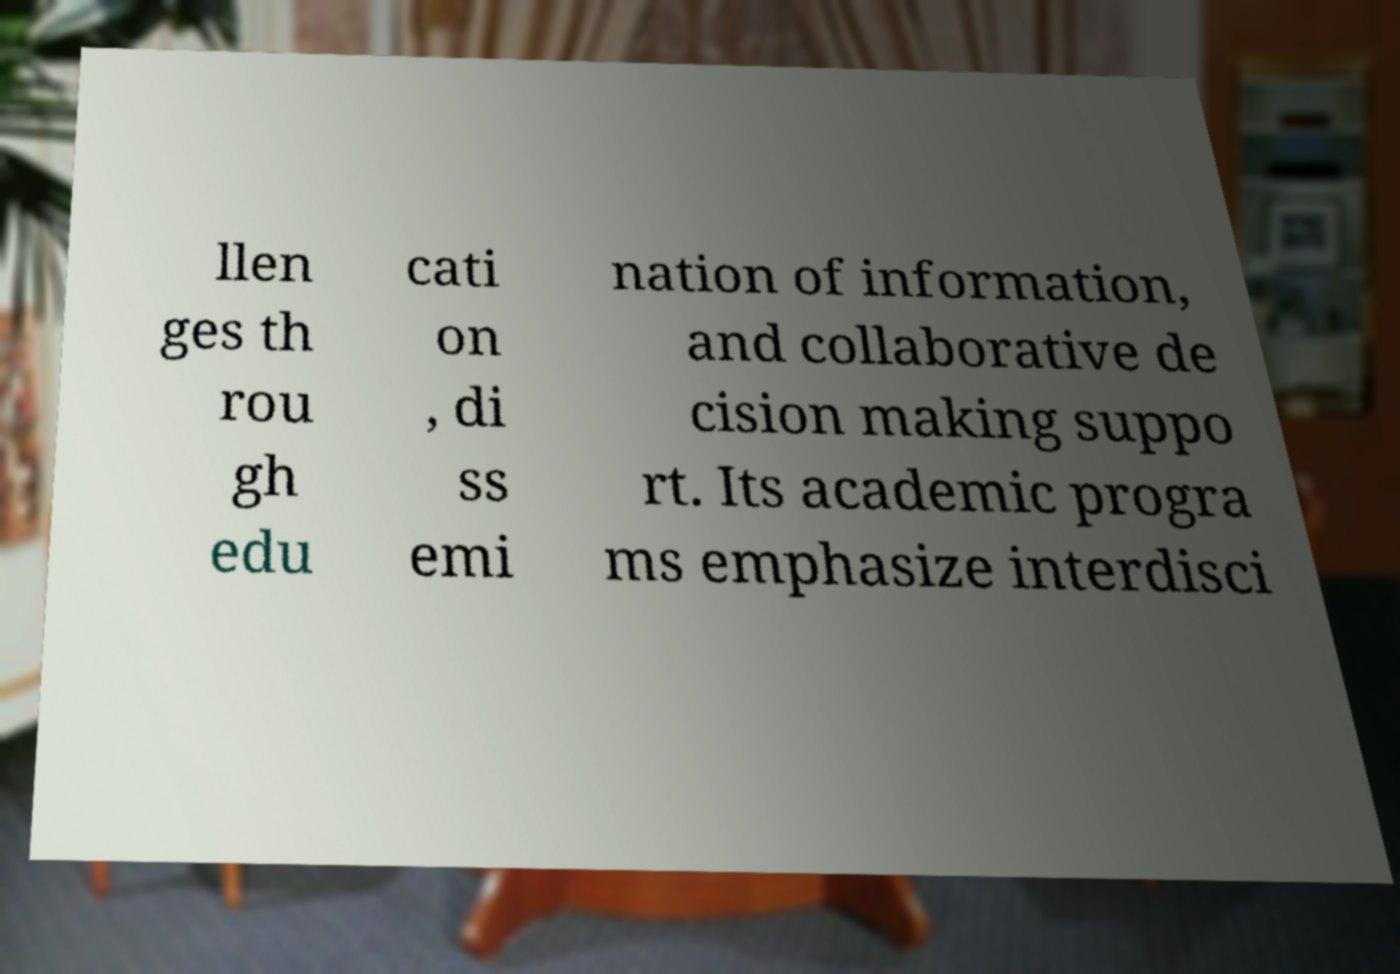Please identify and transcribe the text found in this image. llen ges th rou gh edu cati on , di ss emi nation of information, and collaborative de cision making suppo rt. Its academic progra ms emphasize interdisci 